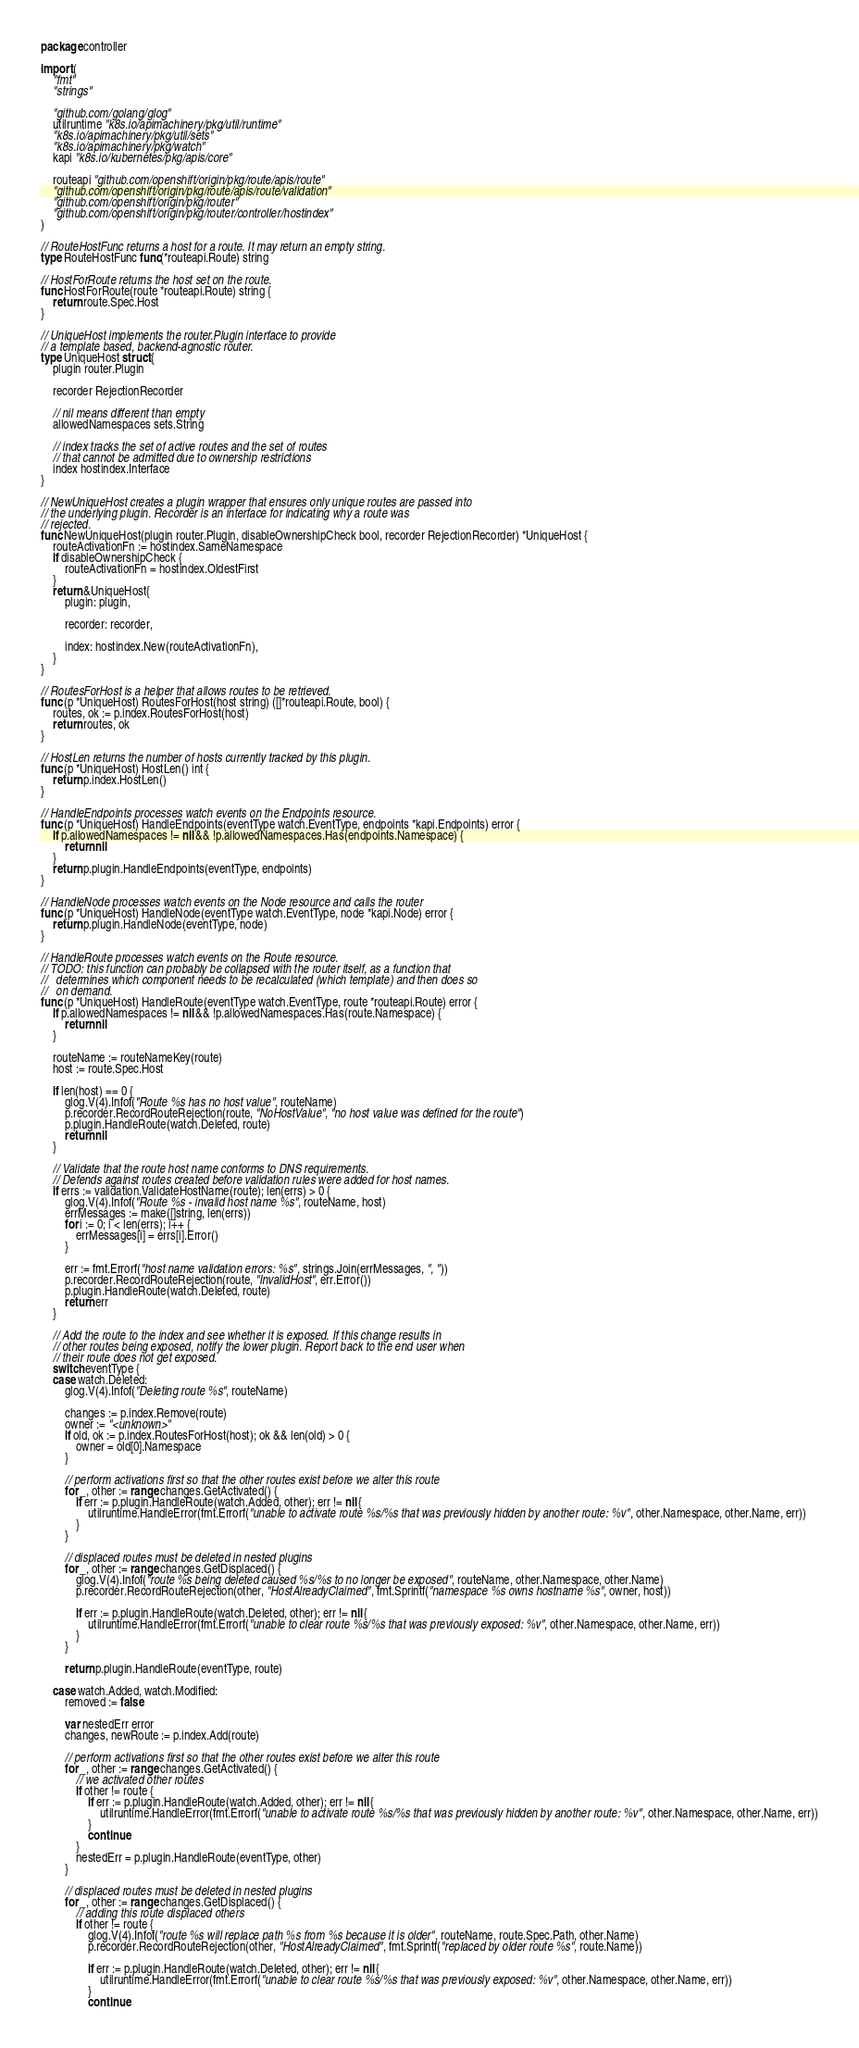<code> <loc_0><loc_0><loc_500><loc_500><_Go_>package controller

import (
	"fmt"
	"strings"

	"github.com/golang/glog"
	utilruntime "k8s.io/apimachinery/pkg/util/runtime"
	"k8s.io/apimachinery/pkg/util/sets"
	"k8s.io/apimachinery/pkg/watch"
	kapi "k8s.io/kubernetes/pkg/apis/core"

	routeapi "github.com/openshift/origin/pkg/route/apis/route"
	"github.com/openshift/origin/pkg/route/apis/route/validation"
	"github.com/openshift/origin/pkg/router"
	"github.com/openshift/origin/pkg/router/controller/hostindex"
)

// RouteHostFunc returns a host for a route. It may return an empty string.
type RouteHostFunc func(*routeapi.Route) string

// HostForRoute returns the host set on the route.
func HostForRoute(route *routeapi.Route) string {
	return route.Spec.Host
}

// UniqueHost implements the router.Plugin interface to provide
// a template based, backend-agnostic router.
type UniqueHost struct {
	plugin router.Plugin

	recorder RejectionRecorder

	// nil means different than empty
	allowedNamespaces sets.String

	// index tracks the set of active routes and the set of routes
	// that cannot be admitted due to ownership restrictions
	index hostindex.Interface
}

// NewUniqueHost creates a plugin wrapper that ensures only unique routes are passed into
// the underlying plugin. Recorder is an interface for indicating why a route was
// rejected.
func NewUniqueHost(plugin router.Plugin, disableOwnershipCheck bool, recorder RejectionRecorder) *UniqueHost {
	routeActivationFn := hostindex.SameNamespace
	if disableOwnershipCheck {
		routeActivationFn = hostindex.OldestFirst
	}
	return &UniqueHost{
		plugin: plugin,

		recorder: recorder,

		index: hostindex.New(routeActivationFn),
	}
}

// RoutesForHost is a helper that allows routes to be retrieved.
func (p *UniqueHost) RoutesForHost(host string) ([]*routeapi.Route, bool) {
	routes, ok := p.index.RoutesForHost(host)
	return routes, ok
}

// HostLen returns the number of hosts currently tracked by this plugin.
func (p *UniqueHost) HostLen() int {
	return p.index.HostLen()
}

// HandleEndpoints processes watch events on the Endpoints resource.
func (p *UniqueHost) HandleEndpoints(eventType watch.EventType, endpoints *kapi.Endpoints) error {
	if p.allowedNamespaces != nil && !p.allowedNamespaces.Has(endpoints.Namespace) {
		return nil
	}
	return p.plugin.HandleEndpoints(eventType, endpoints)
}

// HandleNode processes watch events on the Node resource and calls the router
func (p *UniqueHost) HandleNode(eventType watch.EventType, node *kapi.Node) error {
	return p.plugin.HandleNode(eventType, node)
}

// HandleRoute processes watch events on the Route resource.
// TODO: this function can probably be collapsed with the router itself, as a function that
//   determines which component needs to be recalculated (which template) and then does so
//   on demand.
func (p *UniqueHost) HandleRoute(eventType watch.EventType, route *routeapi.Route) error {
	if p.allowedNamespaces != nil && !p.allowedNamespaces.Has(route.Namespace) {
		return nil
	}

	routeName := routeNameKey(route)
	host := route.Spec.Host

	if len(host) == 0 {
		glog.V(4).Infof("Route %s has no host value", routeName)
		p.recorder.RecordRouteRejection(route, "NoHostValue", "no host value was defined for the route")
		p.plugin.HandleRoute(watch.Deleted, route)
		return nil
	}

	// Validate that the route host name conforms to DNS requirements.
	// Defends against routes created before validation rules were added for host names.
	if errs := validation.ValidateHostName(route); len(errs) > 0 {
		glog.V(4).Infof("Route %s - invalid host name %s", routeName, host)
		errMessages := make([]string, len(errs))
		for i := 0; i < len(errs); i++ {
			errMessages[i] = errs[i].Error()
		}

		err := fmt.Errorf("host name validation errors: %s", strings.Join(errMessages, ", "))
		p.recorder.RecordRouteRejection(route, "InvalidHost", err.Error())
		p.plugin.HandleRoute(watch.Deleted, route)
		return err
	}

	// Add the route to the index and see whether it is exposed. If this change results in
	// other routes being exposed, notify the lower plugin. Report back to the end user when
	// their route does not get exposed.
	switch eventType {
	case watch.Deleted:
		glog.V(4).Infof("Deleting route %s", routeName)

		changes := p.index.Remove(route)
		owner := "<unknown>"
		if old, ok := p.index.RoutesForHost(host); ok && len(old) > 0 {
			owner = old[0].Namespace
		}

		// perform activations first so that the other routes exist before we alter this route
		for _, other := range changes.GetActivated() {
			if err := p.plugin.HandleRoute(watch.Added, other); err != nil {
				utilruntime.HandleError(fmt.Errorf("unable to activate route %s/%s that was previously hidden by another route: %v", other.Namespace, other.Name, err))
			}
		}

		// displaced routes must be deleted in nested plugins
		for _, other := range changes.GetDisplaced() {
			glog.V(4).Infof("route %s being deleted caused %s/%s to no longer be exposed", routeName, other.Namespace, other.Name)
			p.recorder.RecordRouteRejection(other, "HostAlreadyClaimed", fmt.Sprintf("namespace %s owns hostname %s", owner, host))

			if err := p.plugin.HandleRoute(watch.Deleted, other); err != nil {
				utilruntime.HandleError(fmt.Errorf("unable to clear route %s/%s that was previously exposed: %v", other.Namespace, other.Name, err))
			}
		}

		return p.plugin.HandleRoute(eventType, route)

	case watch.Added, watch.Modified:
		removed := false

		var nestedErr error
		changes, newRoute := p.index.Add(route)

		// perform activations first so that the other routes exist before we alter this route
		for _, other := range changes.GetActivated() {
			// we activated other routes
			if other != route {
				if err := p.plugin.HandleRoute(watch.Added, other); err != nil {
					utilruntime.HandleError(fmt.Errorf("unable to activate route %s/%s that was previously hidden by another route: %v", other.Namespace, other.Name, err))
				}
				continue
			}
			nestedErr = p.plugin.HandleRoute(eventType, other)
		}

		// displaced routes must be deleted in nested plugins
		for _, other := range changes.GetDisplaced() {
			// adding this route displaced others
			if other != route {
				glog.V(4).Infof("route %s will replace path %s from %s because it is older", routeName, route.Spec.Path, other.Name)
				p.recorder.RecordRouteRejection(other, "HostAlreadyClaimed", fmt.Sprintf("replaced by older route %s", route.Name))

				if err := p.plugin.HandleRoute(watch.Deleted, other); err != nil {
					utilruntime.HandleError(fmt.Errorf("unable to clear route %s/%s that was previously exposed: %v", other.Namespace, other.Name, err))
				}
				continue</code> 